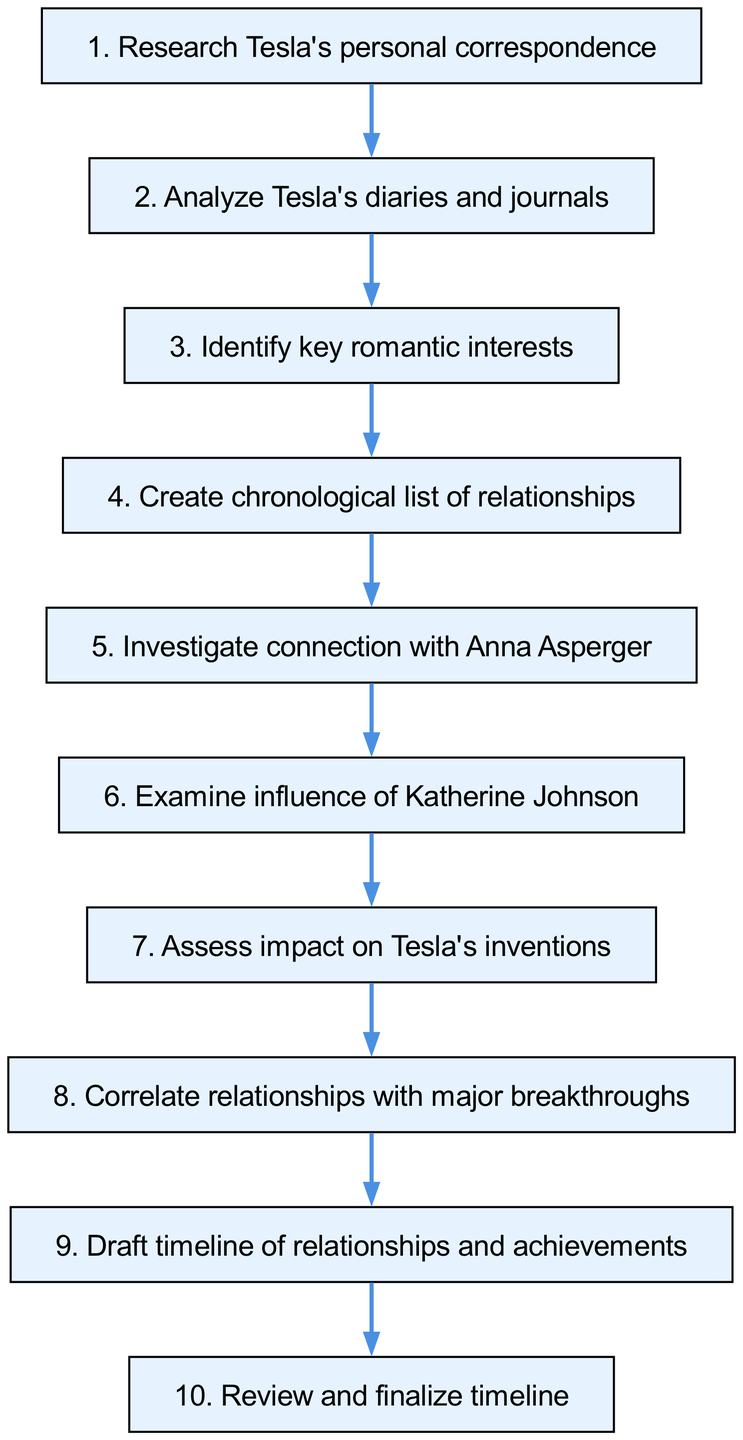What is the first step in the timeline creation process? The first step in the timeline creation process is indicated as "Research Tesla's personal correspondence." This is located at the top of the flowchart and is the starting point of the sequence.
Answer: Research Tesla's personal correspondence How many steps are there in total? By counting all the nodes in the diagram, we find that there are 10 steps represented throughout the flowchart. This includes all items up to the review step.
Answer: 10 What follows after identifying key romantic interests? After identifying key romantic interests, the next specified step is to "Create chronological list of relationships." This connection is evident from the flow direction shown in the diagram.
Answer: Create chronological list of relationships Which relationship is examined just before assessing the impact on Tesla's inventions? The relationship examined just before assessing the impact on Tesla's inventions is the influence of Katherine Johnson. This can be deduced by following the directed path in the flowchart before that particular assessment.
Answer: Influence of Katherine Johnson How many relationships are specifically mentioned in the steps? The flowchart mentions two specific relationships: Anna Asperger and Katherine Johnson. These are highlighted in the investigation and examination steps within the diagram.
Answer: 2 What is the last step in the process? The last step in the process, according to the flowchart, is to "Review and finalize timeline." This indicates the conclusion of all preceding steps and ensures the timeline is complete.
Answer: Review and finalize timeline What is the penultimate step in the timeline process? The penultimate step, which is the step immediately before the last, is to "Draft timeline of relationships and achievements." This step prepares the finalization of the timeline.
Answer: Draft timeline of relationships and achievements What does the seventh step assess? The seventh step assesses the "impact on Tesla's inventions." This is explicitly stated in the flowchart, making it clear what the focus of that evaluation is.
Answer: Impact on Tesla's inventions What are the connections between the relationships and breakthroughs described in the flowchart? The flowchart indicates that there is a specific step for correlating relationships with major breakthroughs, which implies that both aspects are linked together for analysis.
Answer: Correlate relationships with major breakthroughs 